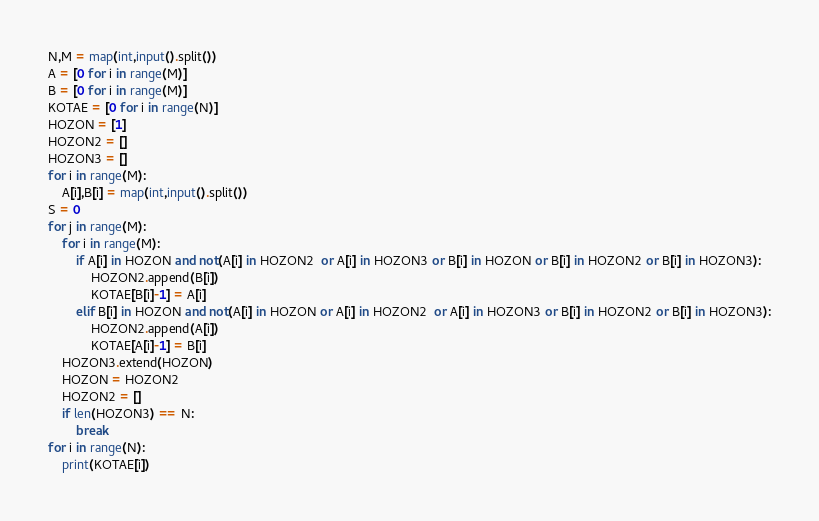Convert code to text. <code><loc_0><loc_0><loc_500><loc_500><_Python_>N,M = map(int,input().split())
A = [0 for i in range(M)]
B = [0 for i in range(M)]
KOTAE = [0 for i in range(N)]
HOZON = [1]
HOZON2 = []
HOZON3 = []
for i in range(M):
    A[i],B[i] = map(int,input().split())
S = 0
for j in range(M):
    for i in range(M):
        if A[i] in HOZON and not(A[i] in HOZON2  or A[i] in HOZON3 or B[i] in HOZON or B[i] in HOZON2 or B[i] in HOZON3):
            HOZON2.append(B[i])
            KOTAE[B[i]-1] = A[i]
        elif B[i] in HOZON and not(A[i] in HOZON or A[i] in HOZON2  or A[i] in HOZON3 or B[i] in HOZON2 or B[i] in HOZON3):
            HOZON2.append(A[i])
            KOTAE[A[i]-1] = B[i]
    HOZON3.extend(HOZON)
    HOZON = HOZON2
    HOZON2 = []
    if len(HOZON3) == N:
        break
for i in range(N):
    print(KOTAE[i])</code> 